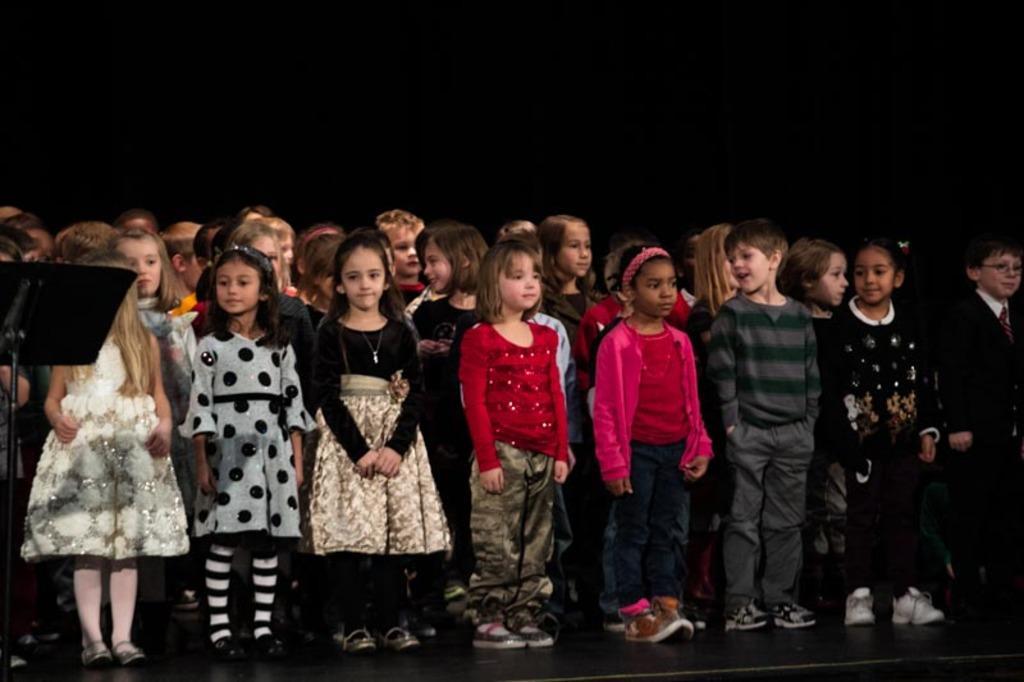Can you describe this image briefly? In this image I can see few children standing on the stage. On the left side there is a metal stand. The background is in black color. 